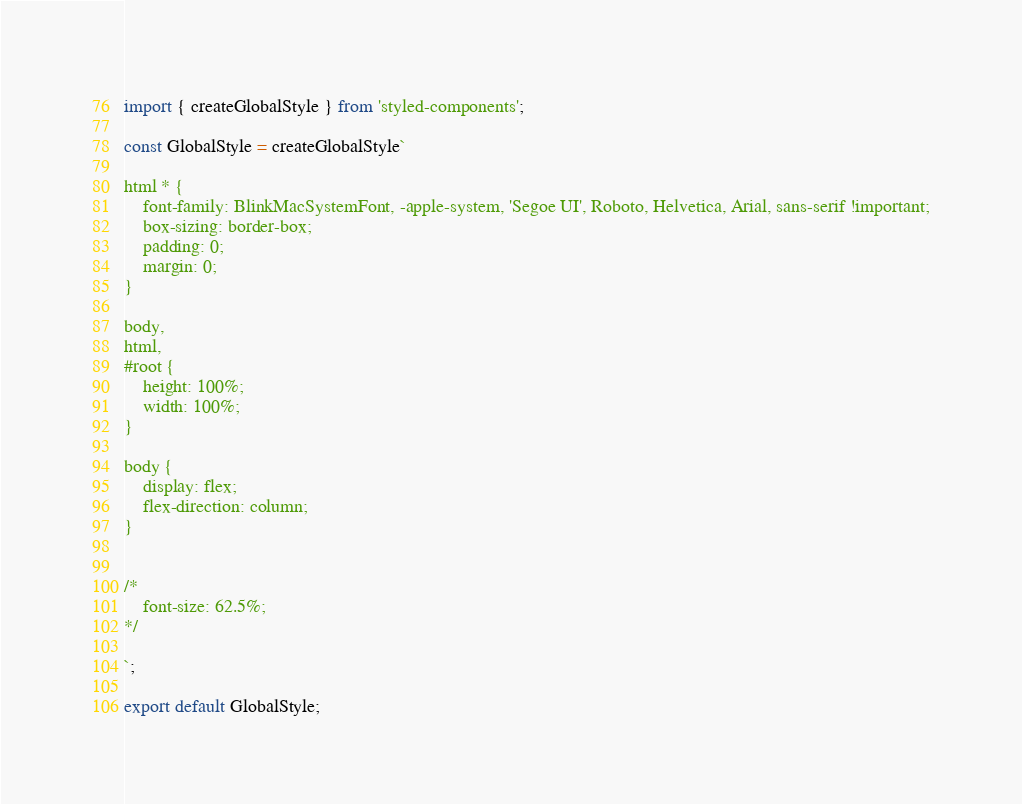<code> <loc_0><loc_0><loc_500><loc_500><_JavaScript_>import { createGlobalStyle } from 'styled-components';

const GlobalStyle = createGlobalStyle`

html * {
    font-family: BlinkMacSystemFont, -apple-system, 'Segoe UI', Roboto, Helvetica, Arial, sans-serif !important;
    box-sizing: border-box;
    padding: 0;
    margin: 0;
}

body,
html,
#root {
    height: 100%;
    width: 100%;
}

body {
    display: flex;
    flex-direction: column;
}


/*
    font-size: 62.5%;
*/

`;

export default GlobalStyle;
</code> 